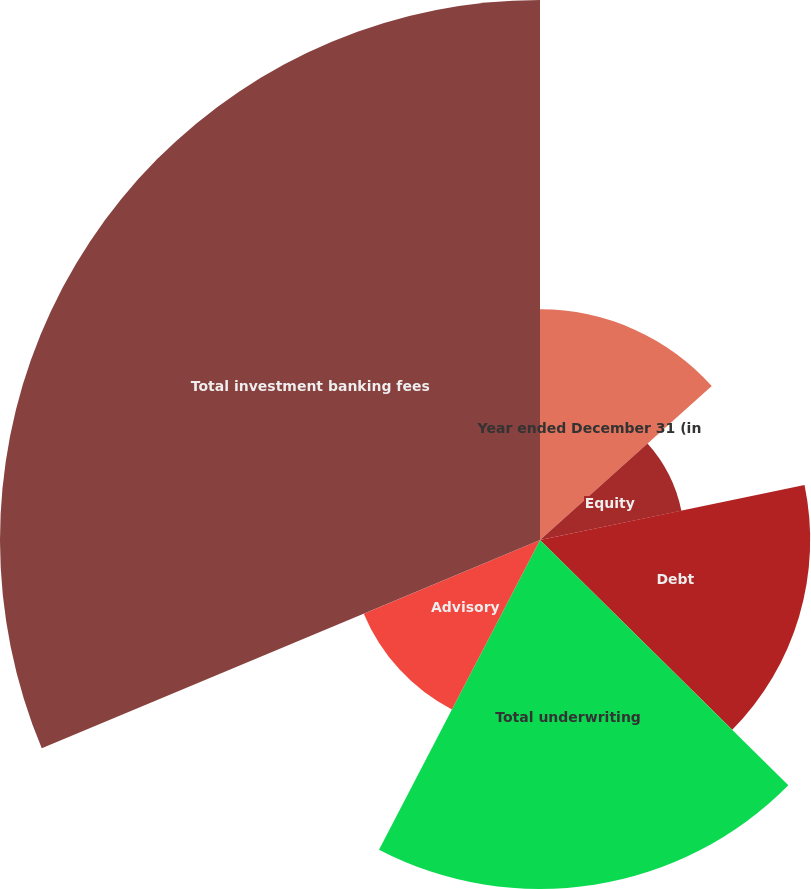<chart> <loc_0><loc_0><loc_500><loc_500><pie_chart><fcel>Year ended December 31 (in<fcel>Equity<fcel>Debt<fcel>Total underwriting<fcel>Advisory<fcel>Total investment banking fees<nl><fcel>13.37%<fcel>8.37%<fcel>15.66%<fcel>20.23%<fcel>11.07%<fcel>31.3%<nl></chart> 